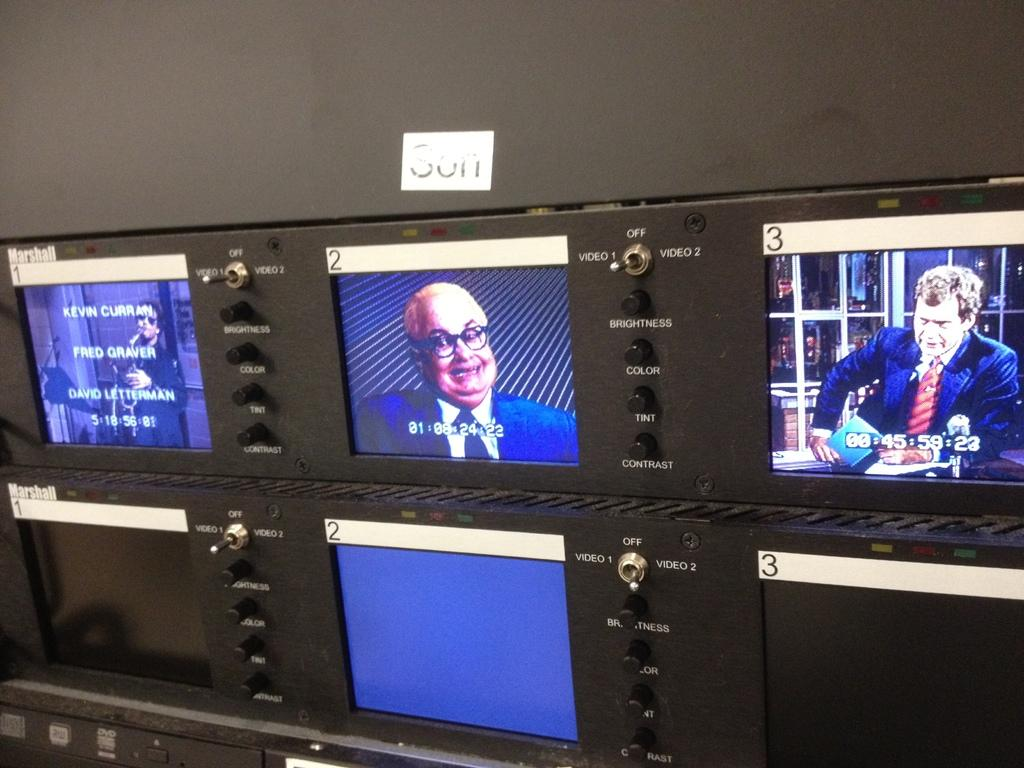<image>
Render a clear and concise summary of the photo. A row of monitors shows images on the top screens, number 3 showing David Letterman. 